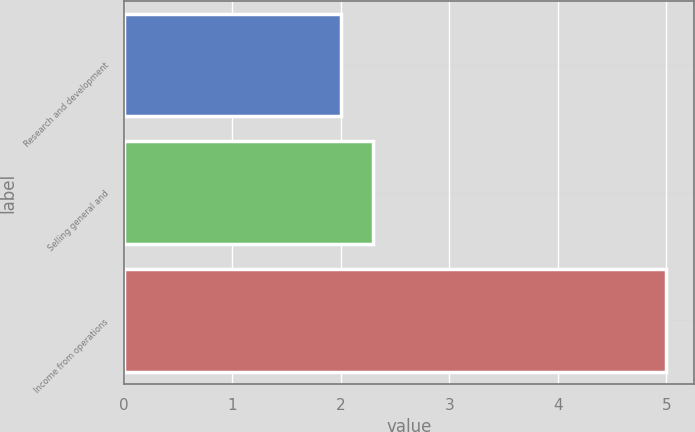Convert chart to OTSL. <chart><loc_0><loc_0><loc_500><loc_500><bar_chart><fcel>Research and development<fcel>Selling general and<fcel>Income from operations<nl><fcel>2<fcel>2.3<fcel>5<nl></chart> 